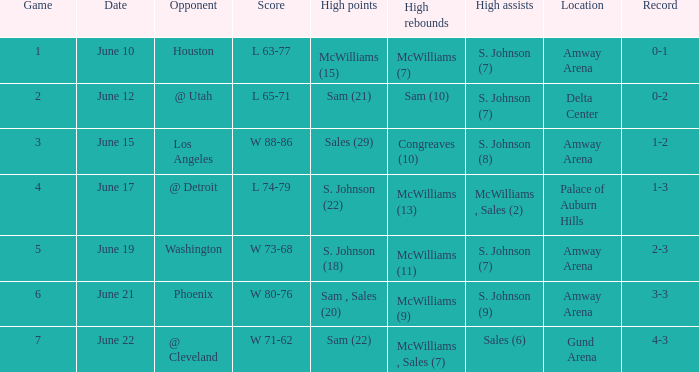Help me parse the entirety of this table. {'header': ['Game', 'Date', 'Opponent', 'Score', 'High points', 'High rebounds', 'High assists', 'Location', 'Record'], 'rows': [['1', 'June 10', 'Houston', 'L 63-77', 'McWilliams (15)', 'McWilliams (7)', 'S. Johnson (7)', 'Amway Arena', '0-1'], ['2', 'June 12', '@ Utah', 'L 65-71', 'Sam (21)', 'Sam (10)', 'S. Johnson (7)', 'Delta Center', '0-2'], ['3', 'June 15', 'Los Angeles', 'W 88-86', 'Sales (29)', 'Congreaves (10)', 'S. Johnson (8)', 'Amway Arena', '1-2'], ['4', 'June 17', '@ Detroit', 'L 74-79', 'S. Johnson (22)', 'McWilliams (13)', 'McWilliams , Sales (2)', 'Palace of Auburn Hills', '1-3'], ['5', 'June 19', 'Washington', 'W 73-68', 'S. Johnson (18)', 'McWilliams (11)', 'S. Johnson (7)', 'Amway Arena', '2-3'], ['6', 'June 21', 'Phoenix', 'W 80-76', 'Sam , Sales (20)', 'McWilliams (9)', 'S. Johnson (9)', 'Amway Arena', '3-3'], ['7', 'June 22', '@ Cleveland', 'W 71-62', 'Sam (22)', 'McWilliams , Sales (7)', 'Sales (6)', 'Gund Arena', '4-3']]} What is the total count of dates between the 63rd and 77th? 1.0. 